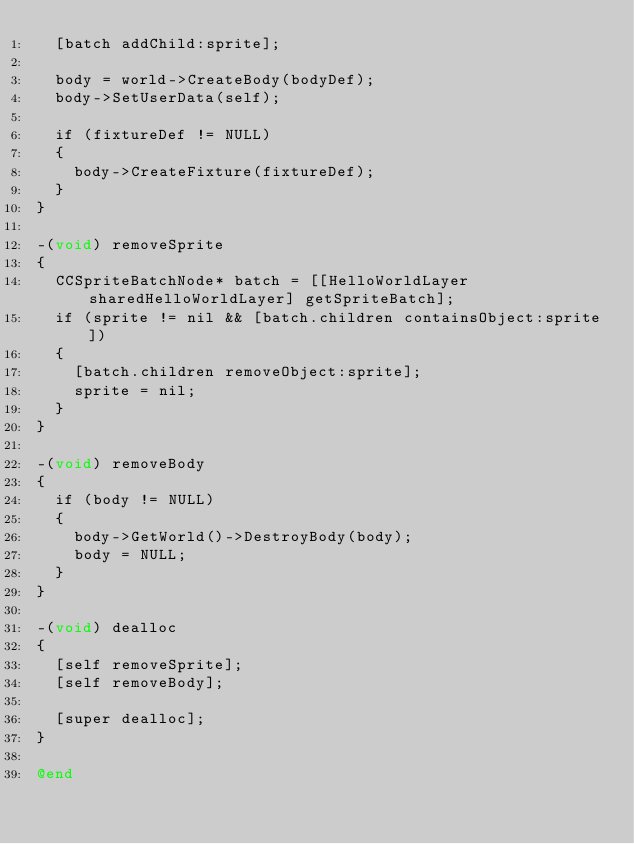<code> <loc_0><loc_0><loc_500><loc_500><_ObjectiveC_>	[batch addChild:sprite];
	
	body = world->CreateBody(bodyDef);
	body->SetUserData(self);
	
	if (fixtureDef != NULL)
	{
		body->CreateFixture(fixtureDef);
	}
}

-(void) removeSprite
{
	CCSpriteBatchNode* batch = [[HelloWorldLayer sharedHelloWorldLayer] getSpriteBatch];
	if (sprite != nil && [batch.children containsObject:sprite])
	{
		[batch.children removeObject:sprite];
		sprite = nil;
	}
}

-(void) removeBody
{
	if (body != NULL)
	{
		body->GetWorld()->DestroyBody(body);
		body = NULL;
	}
}

-(void) dealloc
{
	[self removeSprite];
	[self removeBody];
	
	[super dealloc];
}

@end
</code> 